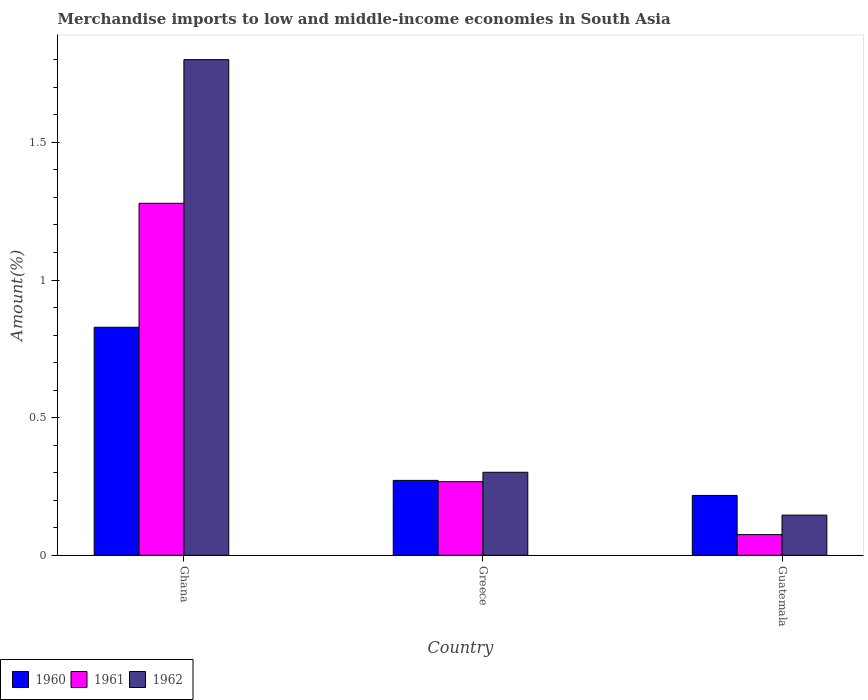How many different coloured bars are there?
Give a very brief answer. 3. What is the percentage of amount earned from merchandise imports in 1962 in Greece?
Offer a terse response. 0.3. Across all countries, what is the maximum percentage of amount earned from merchandise imports in 1961?
Your answer should be compact. 1.28. Across all countries, what is the minimum percentage of amount earned from merchandise imports in 1961?
Provide a short and direct response. 0.08. In which country was the percentage of amount earned from merchandise imports in 1961 maximum?
Offer a very short reply. Ghana. In which country was the percentage of amount earned from merchandise imports in 1961 minimum?
Keep it short and to the point. Guatemala. What is the total percentage of amount earned from merchandise imports in 1961 in the graph?
Give a very brief answer. 1.62. What is the difference between the percentage of amount earned from merchandise imports in 1960 in Greece and that in Guatemala?
Provide a succinct answer. 0.05. What is the difference between the percentage of amount earned from merchandise imports in 1961 in Guatemala and the percentage of amount earned from merchandise imports in 1960 in Ghana?
Give a very brief answer. -0.75. What is the average percentage of amount earned from merchandise imports in 1961 per country?
Give a very brief answer. 0.54. What is the difference between the percentage of amount earned from merchandise imports of/in 1960 and percentage of amount earned from merchandise imports of/in 1961 in Guatemala?
Your answer should be very brief. 0.14. What is the ratio of the percentage of amount earned from merchandise imports in 1961 in Ghana to that in Greece?
Provide a short and direct response. 4.78. Is the percentage of amount earned from merchandise imports in 1960 in Ghana less than that in Greece?
Keep it short and to the point. No. Is the difference between the percentage of amount earned from merchandise imports in 1960 in Ghana and Greece greater than the difference between the percentage of amount earned from merchandise imports in 1961 in Ghana and Greece?
Your answer should be very brief. No. What is the difference between the highest and the second highest percentage of amount earned from merchandise imports in 1961?
Give a very brief answer. -1.01. What is the difference between the highest and the lowest percentage of amount earned from merchandise imports in 1961?
Keep it short and to the point. 1.2. What does the 3rd bar from the left in Greece represents?
Keep it short and to the point. 1962. Is it the case that in every country, the sum of the percentage of amount earned from merchandise imports in 1962 and percentage of amount earned from merchandise imports in 1960 is greater than the percentage of amount earned from merchandise imports in 1961?
Give a very brief answer. Yes. How many bars are there?
Your answer should be very brief. 9. Are all the bars in the graph horizontal?
Give a very brief answer. No. Are the values on the major ticks of Y-axis written in scientific E-notation?
Offer a terse response. No. Does the graph contain any zero values?
Offer a very short reply. No. Where does the legend appear in the graph?
Your answer should be very brief. Bottom left. How many legend labels are there?
Make the answer very short. 3. What is the title of the graph?
Provide a succinct answer. Merchandise imports to low and middle-income economies in South Asia. Does "2011" appear as one of the legend labels in the graph?
Ensure brevity in your answer.  No. What is the label or title of the X-axis?
Keep it short and to the point. Country. What is the label or title of the Y-axis?
Keep it short and to the point. Amount(%). What is the Amount(%) of 1960 in Ghana?
Your answer should be very brief. 0.83. What is the Amount(%) of 1961 in Ghana?
Provide a succinct answer. 1.28. What is the Amount(%) in 1962 in Ghana?
Ensure brevity in your answer.  1.8. What is the Amount(%) in 1960 in Greece?
Your answer should be very brief. 0.27. What is the Amount(%) of 1961 in Greece?
Provide a succinct answer. 0.27. What is the Amount(%) in 1962 in Greece?
Your answer should be very brief. 0.3. What is the Amount(%) of 1960 in Guatemala?
Offer a very short reply. 0.22. What is the Amount(%) of 1961 in Guatemala?
Ensure brevity in your answer.  0.08. What is the Amount(%) of 1962 in Guatemala?
Your answer should be compact. 0.15. Across all countries, what is the maximum Amount(%) in 1960?
Give a very brief answer. 0.83. Across all countries, what is the maximum Amount(%) of 1961?
Offer a terse response. 1.28. Across all countries, what is the maximum Amount(%) in 1962?
Ensure brevity in your answer.  1.8. Across all countries, what is the minimum Amount(%) in 1960?
Your answer should be compact. 0.22. Across all countries, what is the minimum Amount(%) in 1961?
Your answer should be very brief. 0.08. Across all countries, what is the minimum Amount(%) of 1962?
Offer a very short reply. 0.15. What is the total Amount(%) in 1960 in the graph?
Your answer should be compact. 1.32. What is the total Amount(%) of 1961 in the graph?
Ensure brevity in your answer.  1.62. What is the total Amount(%) in 1962 in the graph?
Provide a succinct answer. 2.25. What is the difference between the Amount(%) in 1960 in Ghana and that in Greece?
Give a very brief answer. 0.56. What is the difference between the Amount(%) in 1961 in Ghana and that in Greece?
Provide a short and direct response. 1.01. What is the difference between the Amount(%) of 1962 in Ghana and that in Greece?
Ensure brevity in your answer.  1.5. What is the difference between the Amount(%) in 1960 in Ghana and that in Guatemala?
Give a very brief answer. 0.61. What is the difference between the Amount(%) in 1961 in Ghana and that in Guatemala?
Keep it short and to the point. 1.2. What is the difference between the Amount(%) in 1962 in Ghana and that in Guatemala?
Your answer should be compact. 1.65. What is the difference between the Amount(%) in 1960 in Greece and that in Guatemala?
Offer a terse response. 0.05. What is the difference between the Amount(%) in 1961 in Greece and that in Guatemala?
Provide a short and direct response. 0.19. What is the difference between the Amount(%) of 1962 in Greece and that in Guatemala?
Provide a short and direct response. 0.16. What is the difference between the Amount(%) of 1960 in Ghana and the Amount(%) of 1961 in Greece?
Keep it short and to the point. 0.56. What is the difference between the Amount(%) of 1960 in Ghana and the Amount(%) of 1962 in Greece?
Ensure brevity in your answer.  0.53. What is the difference between the Amount(%) of 1961 in Ghana and the Amount(%) of 1962 in Greece?
Your answer should be very brief. 0.98. What is the difference between the Amount(%) in 1960 in Ghana and the Amount(%) in 1961 in Guatemala?
Keep it short and to the point. 0.75. What is the difference between the Amount(%) of 1960 in Ghana and the Amount(%) of 1962 in Guatemala?
Make the answer very short. 0.68. What is the difference between the Amount(%) in 1961 in Ghana and the Amount(%) in 1962 in Guatemala?
Keep it short and to the point. 1.13. What is the difference between the Amount(%) in 1960 in Greece and the Amount(%) in 1961 in Guatemala?
Provide a succinct answer. 0.2. What is the difference between the Amount(%) in 1960 in Greece and the Amount(%) in 1962 in Guatemala?
Make the answer very short. 0.13. What is the difference between the Amount(%) of 1961 in Greece and the Amount(%) of 1962 in Guatemala?
Your answer should be compact. 0.12. What is the average Amount(%) of 1960 per country?
Give a very brief answer. 0.44. What is the average Amount(%) in 1961 per country?
Provide a succinct answer. 0.54. What is the average Amount(%) in 1962 per country?
Make the answer very short. 0.75. What is the difference between the Amount(%) in 1960 and Amount(%) in 1961 in Ghana?
Your response must be concise. -0.45. What is the difference between the Amount(%) of 1960 and Amount(%) of 1962 in Ghana?
Give a very brief answer. -0.97. What is the difference between the Amount(%) of 1961 and Amount(%) of 1962 in Ghana?
Make the answer very short. -0.52. What is the difference between the Amount(%) of 1960 and Amount(%) of 1961 in Greece?
Your answer should be compact. 0. What is the difference between the Amount(%) of 1960 and Amount(%) of 1962 in Greece?
Your answer should be compact. -0.03. What is the difference between the Amount(%) of 1961 and Amount(%) of 1962 in Greece?
Offer a terse response. -0.03. What is the difference between the Amount(%) in 1960 and Amount(%) in 1961 in Guatemala?
Ensure brevity in your answer.  0.14. What is the difference between the Amount(%) of 1960 and Amount(%) of 1962 in Guatemala?
Keep it short and to the point. 0.07. What is the difference between the Amount(%) of 1961 and Amount(%) of 1962 in Guatemala?
Your answer should be very brief. -0.07. What is the ratio of the Amount(%) of 1960 in Ghana to that in Greece?
Your answer should be very brief. 3.04. What is the ratio of the Amount(%) in 1961 in Ghana to that in Greece?
Provide a succinct answer. 4.78. What is the ratio of the Amount(%) of 1962 in Ghana to that in Greece?
Keep it short and to the point. 5.97. What is the ratio of the Amount(%) in 1960 in Ghana to that in Guatemala?
Make the answer very short. 3.81. What is the ratio of the Amount(%) in 1961 in Ghana to that in Guatemala?
Give a very brief answer. 17.02. What is the ratio of the Amount(%) in 1962 in Ghana to that in Guatemala?
Give a very brief answer. 12.34. What is the ratio of the Amount(%) in 1960 in Greece to that in Guatemala?
Provide a succinct answer. 1.25. What is the ratio of the Amount(%) in 1961 in Greece to that in Guatemala?
Make the answer very short. 3.56. What is the ratio of the Amount(%) of 1962 in Greece to that in Guatemala?
Offer a very short reply. 2.07. What is the difference between the highest and the second highest Amount(%) in 1960?
Give a very brief answer. 0.56. What is the difference between the highest and the second highest Amount(%) in 1961?
Offer a very short reply. 1.01. What is the difference between the highest and the second highest Amount(%) in 1962?
Offer a terse response. 1.5. What is the difference between the highest and the lowest Amount(%) in 1960?
Keep it short and to the point. 0.61. What is the difference between the highest and the lowest Amount(%) in 1961?
Ensure brevity in your answer.  1.2. What is the difference between the highest and the lowest Amount(%) in 1962?
Your answer should be compact. 1.65. 